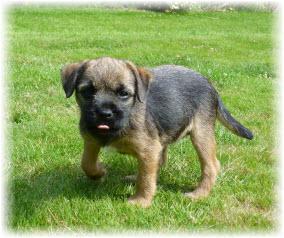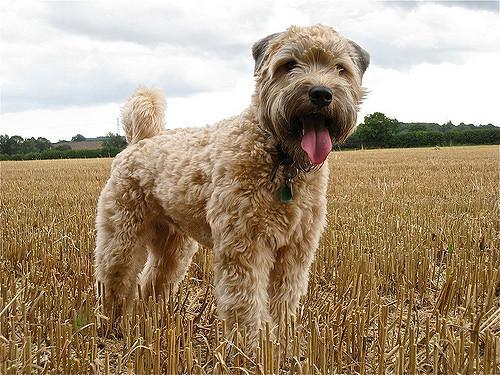The first image is the image on the left, the second image is the image on the right. Examine the images to the left and right. Is the description "Exactly two small dogs are shown in an outdoor field setting." accurate? Answer yes or no. Yes. The first image is the image on the left, the second image is the image on the right. Examine the images to the left and right. Is the description "There are two dogs" accurate? Answer yes or no. Yes. 